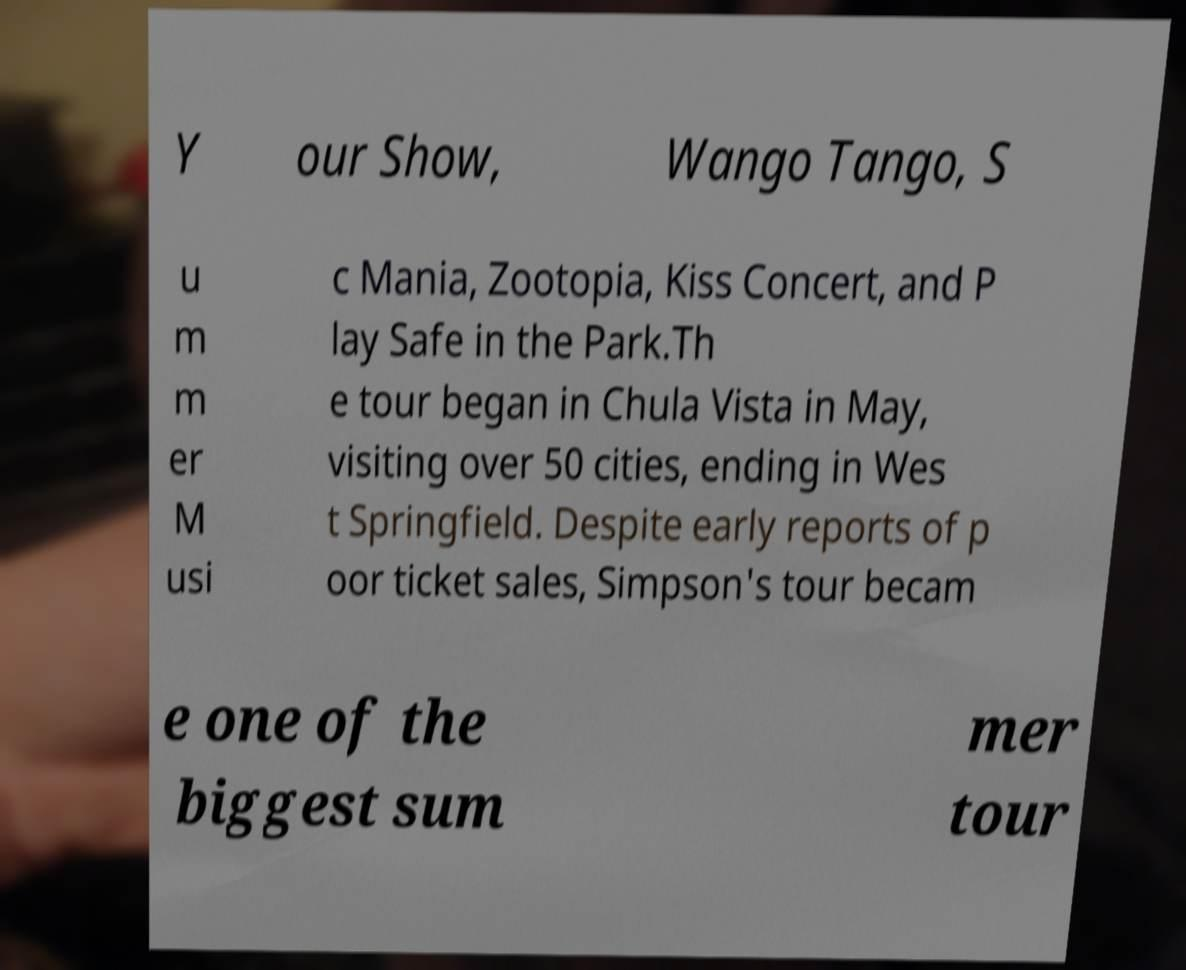Could you extract and type out the text from this image? Y our Show, Wango Tango, S u m m er M usi c Mania, Zootopia, Kiss Concert, and P lay Safe in the Park.Th e tour began in Chula Vista in May, visiting over 50 cities, ending in Wes t Springfield. Despite early reports of p oor ticket sales, Simpson's tour becam e one of the biggest sum mer tour 